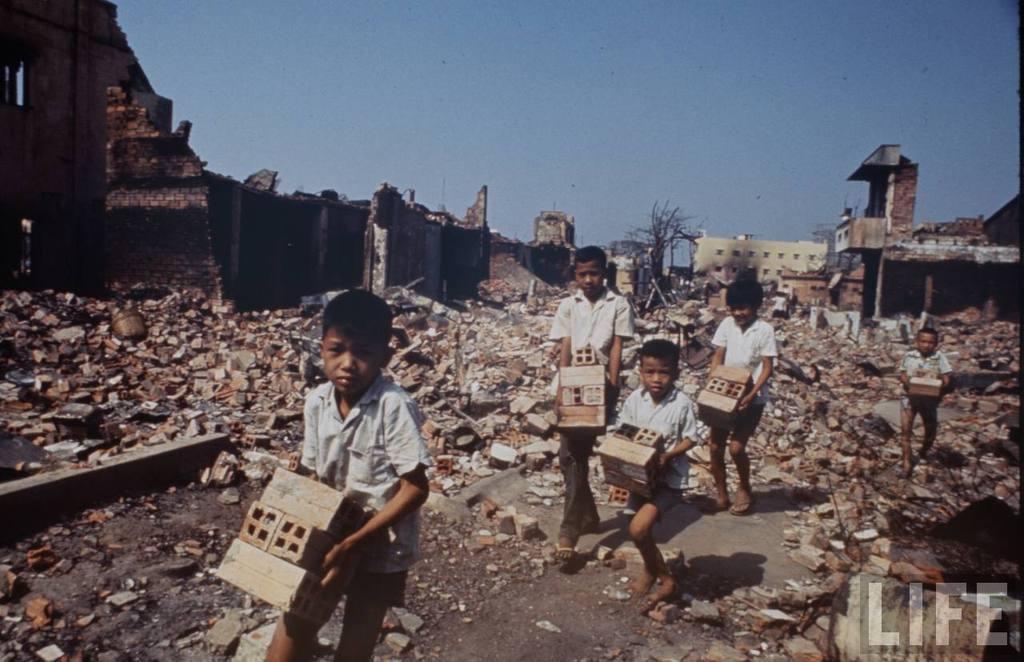Can you describe this image briefly? This is an outside view. Here I can see few children holding bricks in the hands and walking on the ground. In the background there are few buildings collapsed and there is a tree. At the top of the image I can see the sky. 